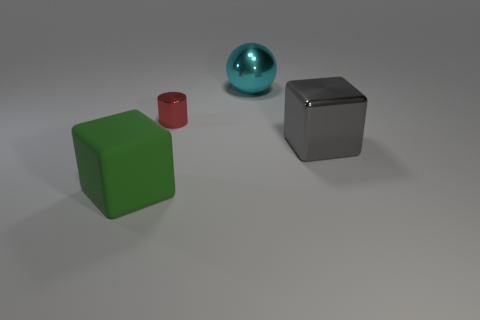Is the number of purple shiny blocks greater than the number of large green blocks?
Provide a succinct answer. No. What is the material of the tiny red cylinder?
Make the answer very short. Metal. Are there any other things that have the same size as the cyan object?
Your answer should be compact. Yes. What size is the other thing that is the same shape as the green object?
Provide a short and direct response. Large. Is there a small cylinder that is behind the block that is left of the large cyan object?
Your answer should be compact. Yes. Is the rubber cube the same color as the small cylinder?
Your response must be concise. No. How many other objects are there of the same shape as the gray object?
Your response must be concise. 1. Are there more red cylinders to the left of the large green block than gray blocks that are behind the cylinder?
Make the answer very short. No. Is the size of the cube right of the matte object the same as the metal thing that is left of the cyan sphere?
Ensure brevity in your answer.  No. What is the shape of the big rubber object?
Your answer should be very brief. Cube. 